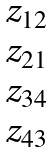Convert formula to latex. <formula><loc_0><loc_0><loc_500><loc_500>\begin{matrix} z _ { 1 2 } \\ z _ { 2 1 } \\ z _ { 3 4 } \\ z _ { 4 3 } \end{matrix}</formula> 